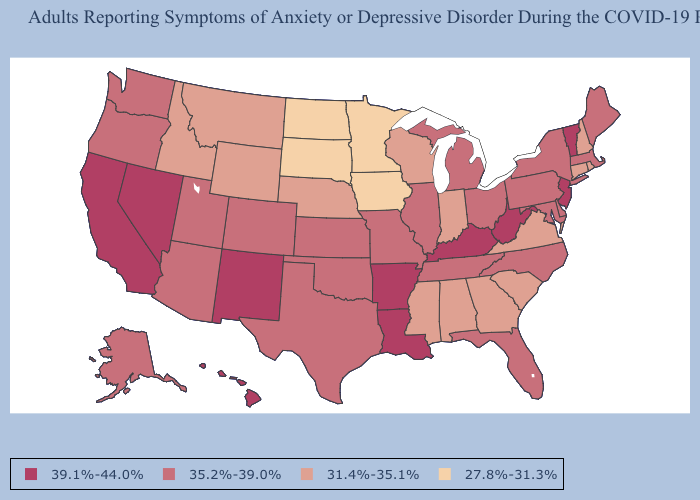Does the first symbol in the legend represent the smallest category?
Concise answer only. No. Does Indiana have a lower value than Montana?
Short answer required. No. What is the value of Texas?
Give a very brief answer. 35.2%-39.0%. Which states have the highest value in the USA?
Concise answer only. Arkansas, California, Hawaii, Kentucky, Louisiana, Nevada, New Jersey, New Mexico, Vermont, West Virginia. Name the states that have a value in the range 27.8%-31.3%?
Give a very brief answer. Iowa, Minnesota, North Dakota, South Dakota. Name the states that have a value in the range 27.8%-31.3%?
Answer briefly. Iowa, Minnesota, North Dakota, South Dakota. Does the map have missing data?
Answer briefly. No. Which states hav the highest value in the Northeast?
Short answer required. New Jersey, Vermont. Does Alaska have the lowest value in the West?
Answer briefly. No. Does Louisiana have the lowest value in the South?
Give a very brief answer. No. Does North Dakota have the same value as Minnesota?
Answer briefly. Yes. What is the value of Connecticut?
Be succinct. 31.4%-35.1%. How many symbols are there in the legend?
Quick response, please. 4. Which states hav the highest value in the South?
Short answer required. Arkansas, Kentucky, Louisiana, West Virginia. What is the value of Oklahoma?
Give a very brief answer. 35.2%-39.0%. 